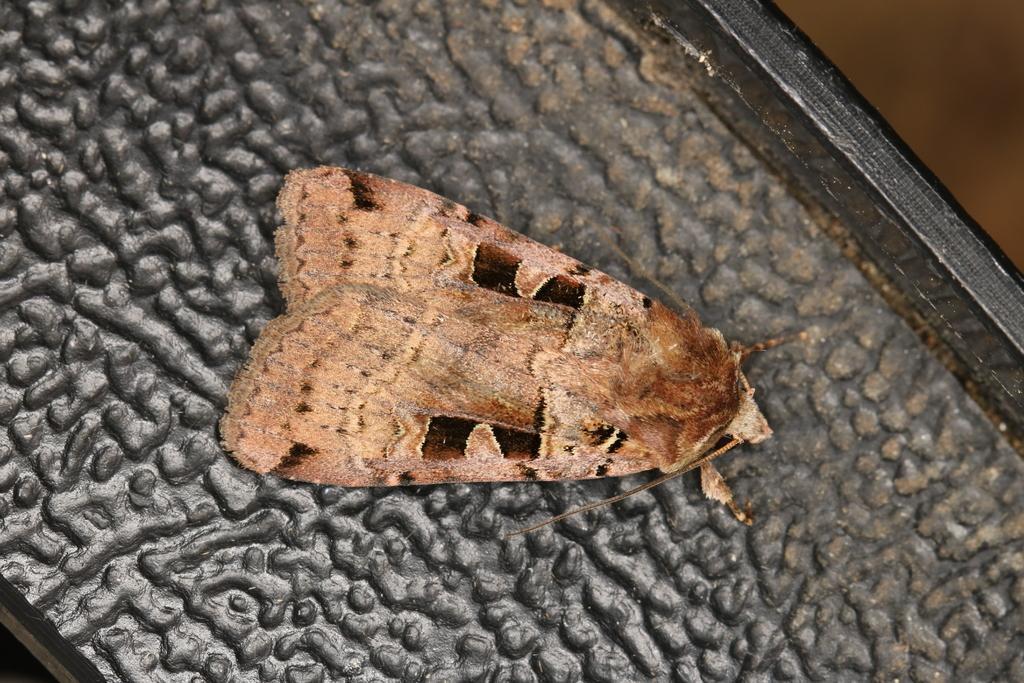Please provide a concise description of this image. In this image, we can see an insect which is colored brown. 